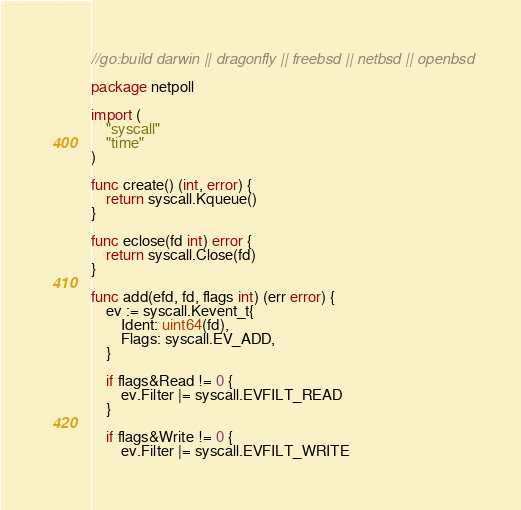Convert code to text. <code><loc_0><loc_0><loc_500><loc_500><_Go_>//go:build darwin || dragonfly || freebsd || netbsd || openbsd

package netpoll

import (
	"syscall"
	"time"
)

func create() (int, error) {
	return syscall.Kqueue()
}

func eclose(fd int) error {
	return syscall.Close(fd)
}

func add(efd, fd, flags int) (err error) {
	ev := syscall.Kevent_t{
		Ident: uint64(fd),
		Flags: syscall.EV_ADD,
	}

	if flags&Read != 0 {
		ev.Filter |= syscall.EVFILT_READ
	}

	if flags&Write != 0 {
		ev.Filter |= syscall.EVFILT_WRITE</code> 